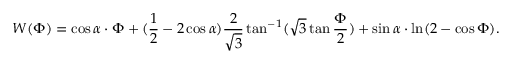Convert formula to latex. <formula><loc_0><loc_0><loc_500><loc_500>W ( \Phi ) = \cos \alpha \cdot \Phi + ( \frac { 1 } { 2 } - 2 \cos \alpha ) \frac { 2 } { \sqrt { 3 } } \tan ^ { - 1 } ( \sqrt { 3 } \tan \frac { \Phi } { 2 } ) + \sin \alpha \cdot \ln ( 2 - \cos \Phi ) .</formula> 